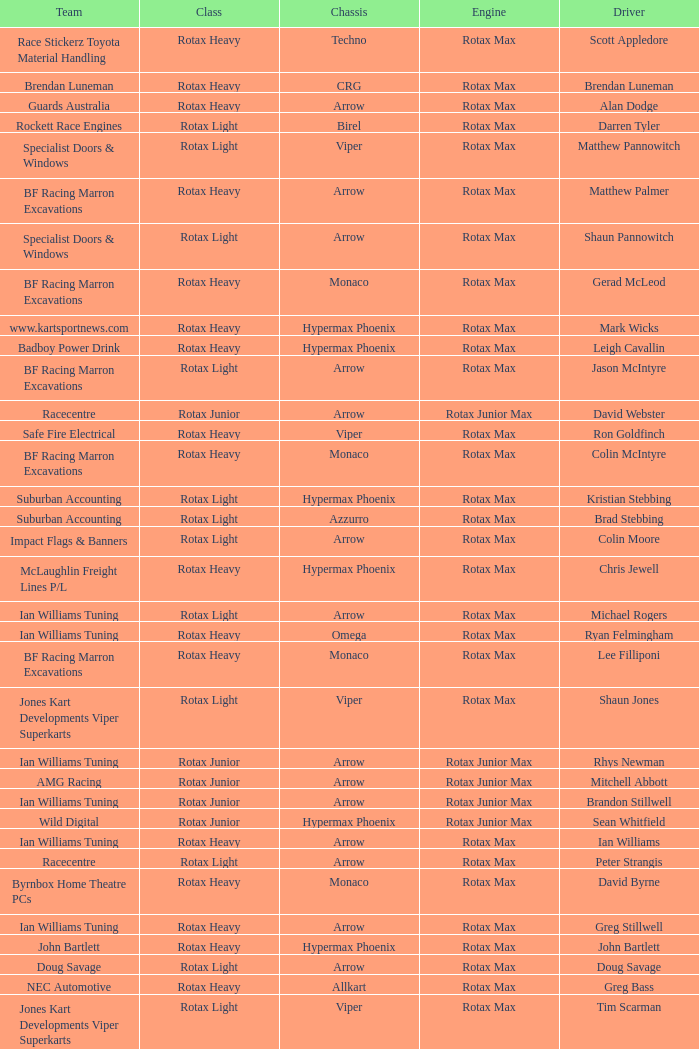Which team does Colin Moore drive for? Impact Flags & Banners. Could you parse the entire table as a dict? {'header': ['Team', 'Class', 'Chassis', 'Engine', 'Driver'], 'rows': [['Race Stickerz Toyota Material Handling', 'Rotax Heavy', 'Techno', 'Rotax Max', 'Scott Appledore'], ['Brendan Luneman', 'Rotax Heavy', 'CRG', 'Rotax Max', 'Brendan Luneman'], ['Guards Australia', 'Rotax Heavy', 'Arrow', 'Rotax Max', 'Alan Dodge'], ['Rockett Race Engines', 'Rotax Light', 'Birel', 'Rotax Max', 'Darren Tyler'], ['Specialist Doors & Windows', 'Rotax Light', 'Viper', 'Rotax Max', 'Matthew Pannowitch'], ['BF Racing Marron Excavations', 'Rotax Heavy', 'Arrow', 'Rotax Max', 'Matthew Palmer'], ['Specialist Doors & Windows', 'Rotax Light', 'Arrow', 'Rotax Max', 'Shaun Pannowitch'], ['BF Racing Marron Excavations', 'Rotax Heavy', 'Monaco', 'Rotax Max', 'Gerad McLeod'], ['www.kartsportnews.com', 'Rotax Heavy', 'Hypermax Phoenix', 'Rotax Max', 'Mark Wicks'], ['Badboy Power Drink', 'Rotax Heavy', 'Hypermax Phoenix', 'Rotax Max', 'Leigh Cavallin'], ['BF Racing Marron Excavations', 'Rotax Light', 'Arrow', 'Rotax Max', 'Jason McIntyre'], ['Racecentre', 'Rotax Junior', 'Arrow', 'Rotax Junior Max', 'David Webster'], ['Safe Fire Electrical', 'Rotax Heavy', 'Viper', 'Rotax Max', 'Ron Goldfinch'], ['BF Racing Marron Excavations', 'Rotax Heavy', 'Monaco', 'Rotax Max', 'Colin McIntyre'], ['Suburban Accounting', 'Rotax Light', 'Hypermax Phoenix', 'Rotax Max', 'Kristian Stebbing'], ['Suburban Accounting', 'Rotax Light', 'Azzurro', 'Rotax Max', 'Brad Stebbing'], ['Impact Flags & Banners', 'Rotax Light', 'Arrow', 'Rotax Max', 'Colin Moore'], ['McLaughlin Freight Lines P/L', 'Rotax Heavy', 'Hypermax Phoenix', 'Rotax Max', 'Chris Jewell'], ['Ian Williams Tuning', 'Rotax Light', 'Arrow', 'Rotax Max', 'Michael Rogers'], ['Ian Williams Tuning', 'Rotax Heavy', 'Omega', 'Rotax Max', 'Ryan Felmingham'], ['BF Racing Marron Excavations', 'Rotax Heavy', 'Monaco', 'Rotax Max', 'Lee Filliponi'], ['Jones Kart Developments Viper Superkarts', 'Rotax Light', 'Viper', 'Rotax Max', 'Shaun Jones'], ['Ian Williams Tuning', 'Rotax Junior', 'Arrow', 'Rotax Junior Max', 'Rhys Newman'], ['AMG Racing', 'Rotax Junior', 'Arrow', 'Rotax Junior Max', 'Mitchell Abbott'], ['Ian Williams Tuning', 'Rotax Junior', 'Arrow', 'Rotax Junior Max', 'Brandon Stillwell'], ['Wild Digital', 'Rotax Junior', 'Hypermax Phoenix', 'Rotax Junior Max', 'Sean Whitfield'], ['Ian Williams Tuning', 'Rotax Heavy', 'Arrow', 'Rotax Max', 'Ian Williams'], ['Racecentre', 'Rotax Light', 'Arrow', 'Rotax Max', 'Peter Strangis'], ['Byrnbox Home Theatre PCs', 'Rotax Heavy', 'Monaco', 'Rotax Max', 'David Byrne'], ['Ian Williams Tuning', 'Rotax Heavy', 'Arrow', 'Rotax Max', 'Greg Stillwell'], ['John Bartlett', 'Rotax Heavy', 'Hypermax Phoenix', 'Rotax Max', 'John Bartlett'], ['Doug Savage', 'Rotax Light', 'Arrow', 'Rotax Max', 'Doug Savage'], ['NEC Automotive', 'Rotax Heavy', 'Allkart', 'Rotax Max', 'Greg Bass'], ['Jones Kart Developments Viper Superkarts', 'Rotax Light', 'Viper', 'Rotax Max', 'Tim Scarman'], ['TWR Raceline Seating', 'Rotax Heavy', 'Arrow', 'Rotax Max', 'Rod Clarke']]} 